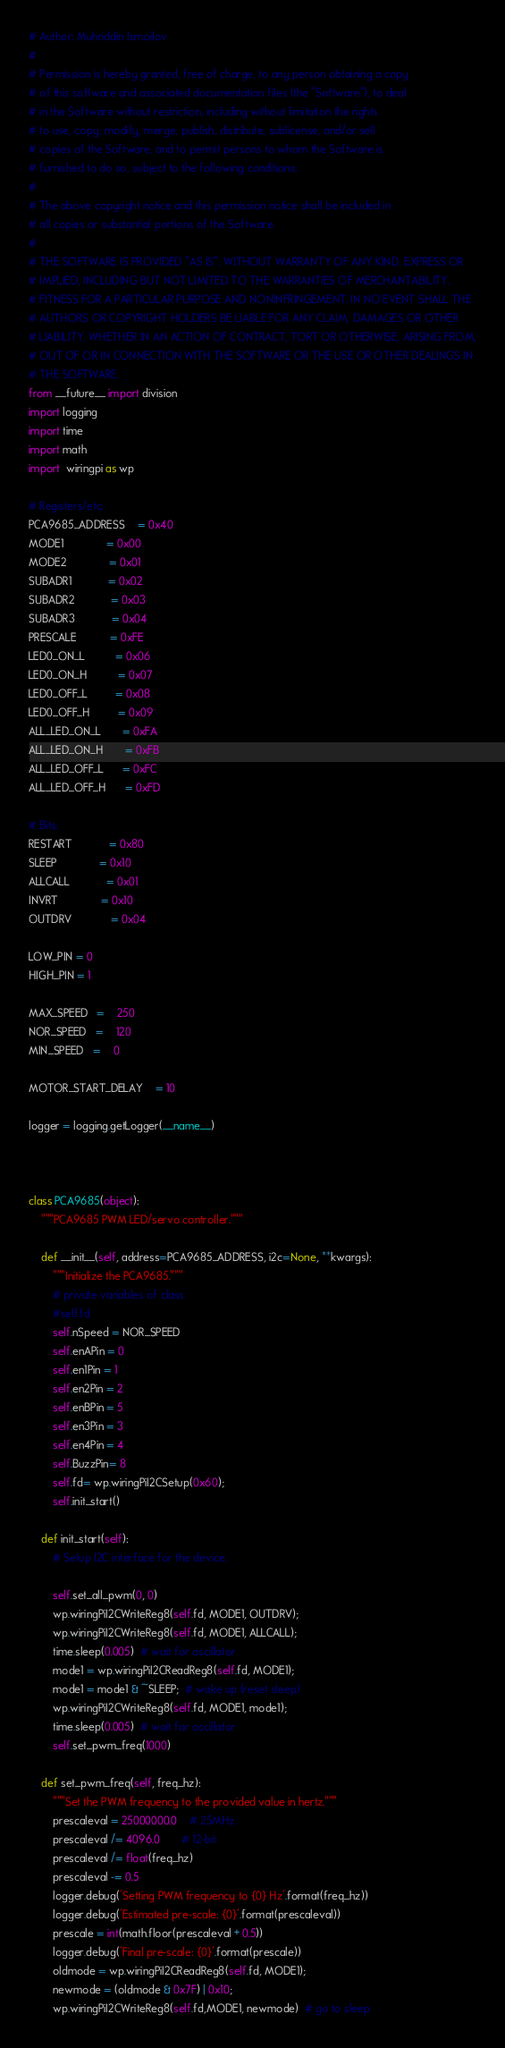<code> <loc_0><loc_0><loc_500><loc_500><_Python_># Author: Muhriddin Ismoilov
#
# Permission is hereby granted, free of charge, to any person obtaining a copy
# of this software and associated documentation files (the "Software"), to deal
# in the Software without restriction, including without limitation the rights
# to use, copy, modify, merge, publish, distribute, sublicense, and/or sell
# copies of the Software, and to permit persons to whom the Software is
# furnished to do so, subject to the following conditions:
#
# The above copyright notice and this permission notice shall be included in
# all copies or substantial portions of the Software.
#
# THE SOFTWARE IS PROVIDED "AS IS", WITHOUT WARRANTY OF ANY KIND, EXPRESS OR
# IMPLIED, INCLUDING BUT NOT LIMITED TO THE WARRANTIES OF MERCHANTABILITY,
# FITNESS FOR A PARTICULAR PURPOSE AND NONINFRINGEMENT. IN NO EVENT SHALL THE
# AUTHORS OR COPYRIGHT HOLDERS BE LIABLE FOR ANY CLAIM, DAMAGES OR OTHER
# LIABILITY, WHETHER IN AN ACTION OF CONTRACT, TORT OR OTHERWISE, ARISING FROM,
# OUT OF OR IN CONNECTION WITH THE SOFTWARE OR THE USE OR OTHER DEALINGS IN
# THE SOFTWARE.
from __future__ import division
import logging
import time
import math
import  wiringpi as wp

# Registers/etc:
PCA9685_ADDRESS    = 0x40
MODE1              = 0x00
MODE2              = 0x01
SUBADR1            = 0x02
SUBADR2            = 0x03
SUBADR3            = 0x04
PRESCALE           = 0xFE
LED0_ON_L          = 0x06
LED0_ON_H          = 0x07
LED0_OFF_L         = 0x08
LED0_OFF_H         = 0x09
ALL_LED_ON_L       = 0xFA
ALL_LED_ON_H       = 0xFB
ALL_LED_OFF_L      = 0xFC
ALL_LED_OFF_H      = 0xFD

# Bits:
RESTART            = 0x80
SLEEP              = 0x10
ALLCALL            = 0x01
INVRT              = 0x10
OUTDRV             = 0x04

LOW_PIN = 0
HIGH_PIN = 1

MAX_SPEED   =   	250
NOR_SPEED   =   	120
MIN_SPEED   =   	0

MOTOR_START_DELAY	= 10 

logger = logging.getLogger(__name__)



class PCA9685(object):
    """PCA9685 PWM LED/servo controller."""

    def __init__(self, address=PCA9685_ADDRESS, i2c=None, **kwargs):
        """Initialize the PCA9685."""
        # private variables of class
        #self.fd
        self.nSpeed = NOR_SPEED
        self.enAPin = 0
        self.en1Pin = 1
        self.en2Pin = 2
        self.enBPin = 5
        self.en3Pin = 3
        self.en4Pin = 4
        self.BuzzPin= 8
        self.fd= wp.wiringPiI2CSetup(0x60);
        self.init_start()
    
    def init_start(self):
        # Setup I2C interface for the device.
        
        self.set_all_pwm(0, 0)
        wp.wiringPiI2CWriteReg8(self.fd, MODE1, OUTDRV);
        wp.wiringPiI2CWriteReg8(self.fd, MODE1, ALLCALL);
        time.sleep(0.005)  # wait for oscillator
        mode1 = wp.wiringPiI2CReadReg8(self.fd, MODE1);
        mode1 = mode1 & ~SLEEP;  # wake up (reset sleep)
        wp.wiringPiI2CWriteReg8(self.fd, MODE1, mode1);
        time.sleep(0.005)  # wait for oscillator
        self.set_pwm_freq(1000)

    def set_pwm_freq(self, freq_hz):
        """Set the PWM frequency to the provided value in hertz."""
        prescaleval = 25000000.0    # 25MHz
        prescaleval /= 4096.0       # 12-bit
        prescaleval /= float(freq_hz)
        prescaleval -= 0.5
        logger.debug('Setting PWM frequency to {0} Hz'.format(freq_hz))
        logger.debug('Estimated pre-scale: {0}'.format(prescaleval))
        prescale = int(math.floor(prescaleval + 0.5))
        logger.debug('Final pre-scale: {0}'.format(prescale))
        oldmode = wp.wiringPiI2CReadReg8(self.fd, MODE1);
        newmode = (oldmode & 0x7F) | 0x10;           
        wp.wiringPiI2CWriteReg8(self.fd,MODE1, newmode)  # go to sleep</code> 